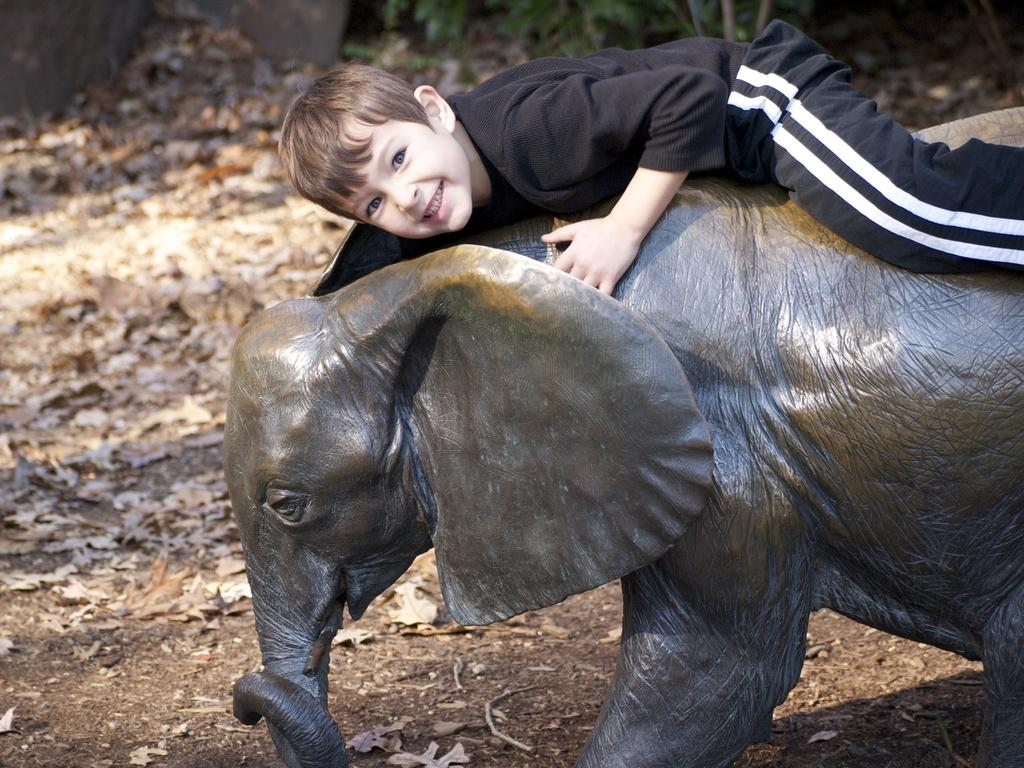Who is the main subject in the image? There is a boy in the image. What is the boy doing in the image? The boy is lying on an elephant sculpture. What type of quartz is the boy holding in the image? There is no quartz present in the image; the boy is lying on an elephant sculpture. 